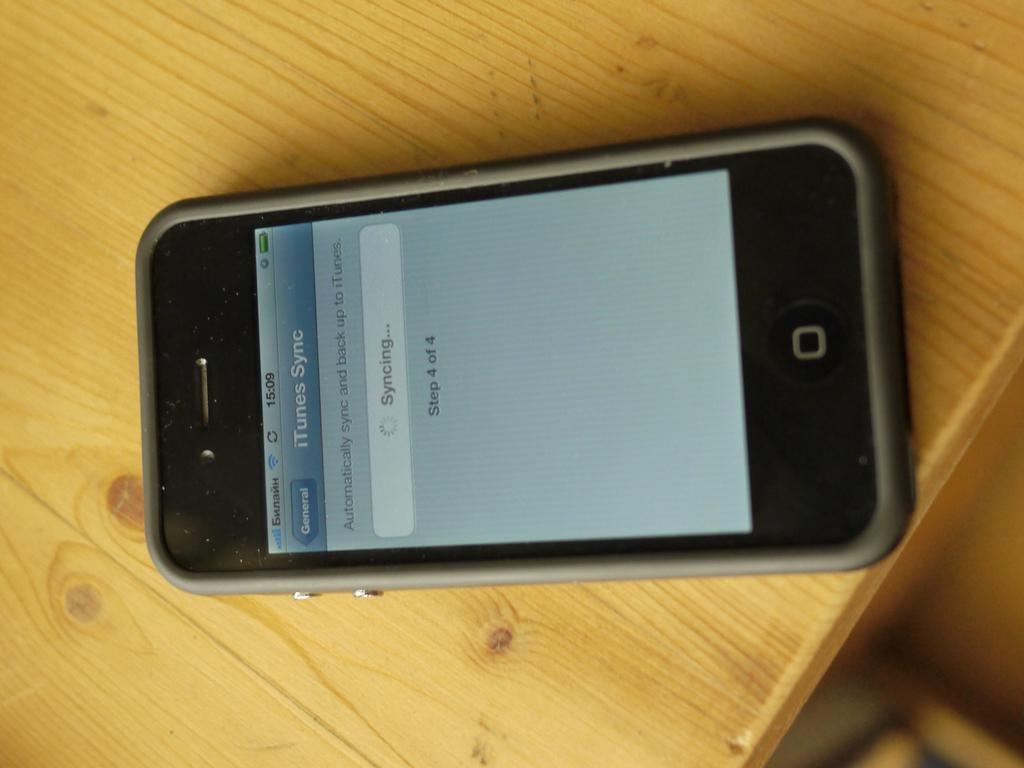<image>
Summarize the visual content of the image. A smart phone  that shows a display reading iTunes Sync. 